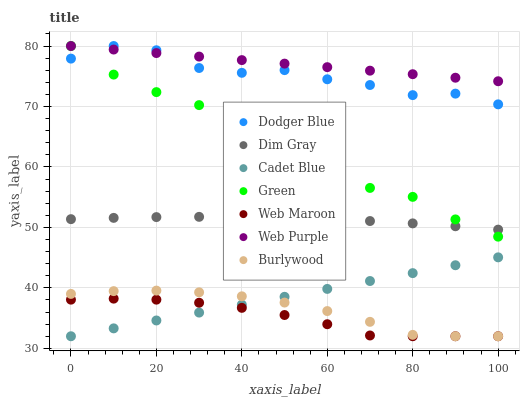Does Web Maroon have the minimum area under the curve?
Answer yes or no. Yes. Does Web Purple have the maximum area under the curve?
Answer yes or no. Yes. Does Burlywood have the minimum area under the curve?
Answer yes or no. No. Does Burlywood have the maximum area under the curve?
Answer yes or no. No. Is Cadet Blue the smoothest?
Answer yes or no. Yes. Is Dodger Blue the roughest?
Answer yes or no. Yes. Is Burlywood the smoothest?
Answer yes or no. No. Is Burlywood the roughest?
Answer yes or no. No. Does Cadet Blue have the lowest value?
Answer yes or no. Yes. Does Web Purple have the lowest value?
Answer yes or no. No. Does Dodger Blue have the highest value?
Answer yes or no. Yes. Does Burlywood have the highest value?
Answer yes or no. No. Is Burlywood less than Dim Gray?
Answer yes or no. Yes. Is Dodger Blue greater than Cadet Blue?
Answer yes or no. Yes. Does Burlywood intersect Web Maroon?
Answer yes or no. Yes. Is Burlywood less than Web Maroon?
Answer yes or no. No. Is Burlywood greater than Web Maroon?
Answer yes or no. No. Does Burlywood intersect Dim Gray?
Answer yes or no. No. 